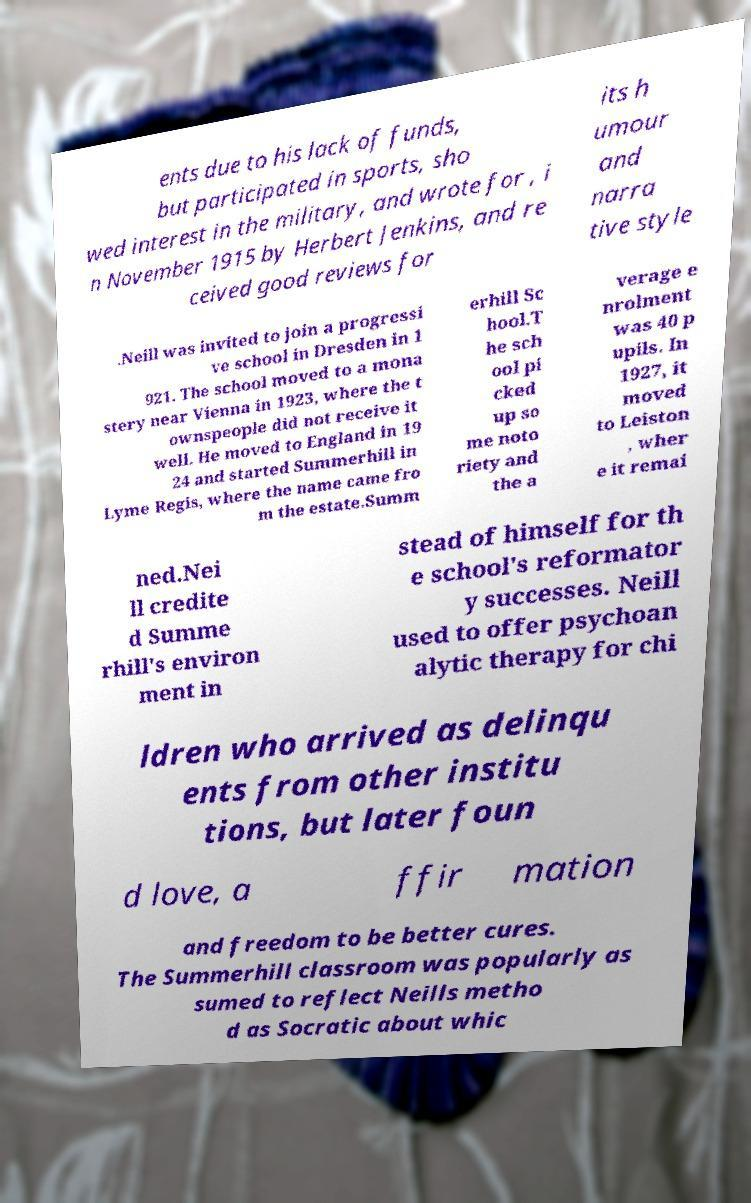Please identify and transcribe the text found in this image. ents due to his lack of funds, but participated in sports, sho wed interest in the military, and wrote for , i n November 1915 by Herbert Jenkins, and re ceived good reviews for its h umour and narra tive style .Neill was invited to join a progressi ve school in Dresden in 1 921. The school moved to a mona stery near Vienna in 1923, where the t ownspeople did not receive it well. He moved to England in 19 24 and started Summerhill in Lyme Regis, where the name came fro m the estate.Summ erhill Sc hool.T he sch ool pi cked up so me noto riety and the a verage e nrolment was 40 p upils. In 1927, it moved to Leiston , wher e it remai ned.Nei ll credite d Summe rhill's environ ment in stead of himself for th e school's reformator y successes. Neill used to offer psychoan alytic therapy for chi ldren who arrived as delinqu ents from other institu tions, but later foun d love, a ffir mation and freedom to be better cures. The Summerhill classroom was popularly as sumed to reflect Neills metho d as Socratic about whic 